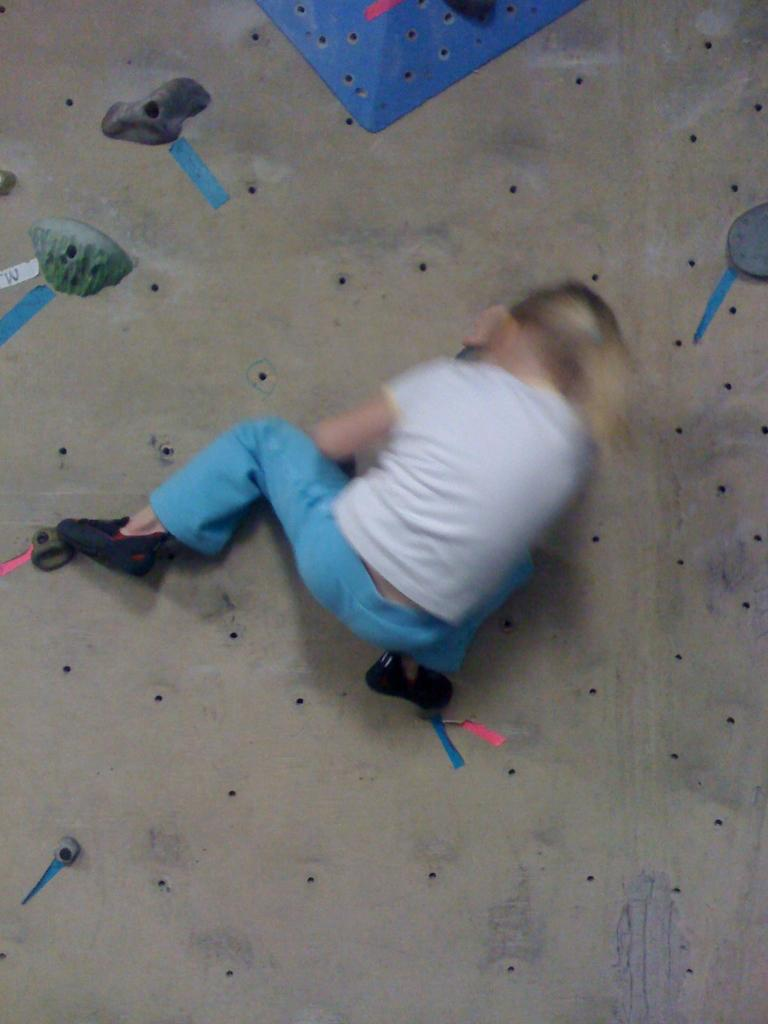What is the main subject of the image? The main subject of the image is a child. What activity is the child engaged in? The child is performing bouldering. Can you describe the setting of the image? The child is doing bouldering over a place. What type of lift can be seen in the image? There is no lift present in the image; it features a child performing bouldering over a place. How does the child's growth affect their bouldering performance in the image? The image does not provide information about the child's growth, so it cannot be determined how it might affect their bouldering performance. 